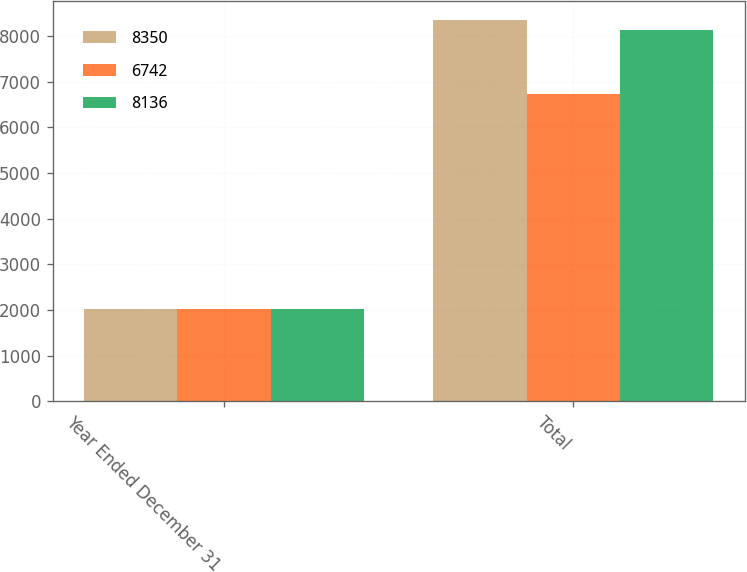<chart> <loc_0><loc_0><loc_500><loc_500><stacked_bar_chart><ecel><fcel>Year Ended December 31<fcel>Total<nl><fcel>8350<fcel>2018<fcel>8350<nl><fcel>6742<fcel>2017<fcel>6742<nl><fcel>8136<fcel>2016<fcel>8136<nl></chart> 